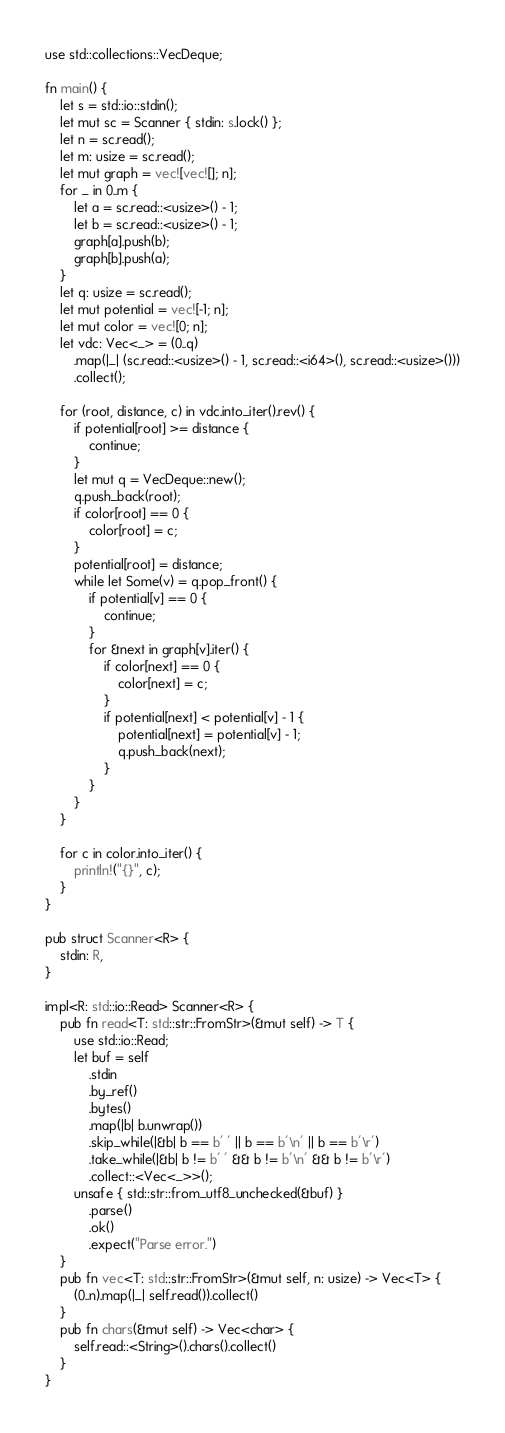<code> <loc_0><loc_0><loc_500><loc_500><_Rust_>use std::collections::VecDeque;

fn main() {
    let s = std::io::stdin();
    let mut sc = Scanner { stdin: s.lock() };
    let n = sc.read();
    let m: usize = sc.read();
    let mut graph = vec![vec![]; n];
    for _ in 0..m {
        let a = sc.read::<usize>() - 1;
        let b = sc.read::<usize>() - 1;
        graph[a].push(b);
        graph[b].push(a);
    }
    let q: usize = sc.read();
    let mut potential = vec![-1; n];
    let mut color = vec![0; n];
    let vdc: Vec<_> = (0..q)
        .map(|_| (sc.read::<usize>() - 1, sc.read::<i64>(), sc.read::<usize>()))
        .collect();

    for (root, distance, c) in vdc.into_iter().rev() {
        if potential[root] >= distance {
            continue;
        }
        let mut q = VecDeque::new();
        q.push_back(root);
        if color[root] == 0 {
            color[root] = c;
        }
        potential[root] = distance;
        while let Some(v) = q.pop_front() {
            if potential[v] == 0 {
                continue;
            }
            for &next in graph[v].iter() {
                if color[next] == 0 {
                    color[next] = c;
                }
                if potential[next] < potential[v] - 1 {
                    potential[next] = potential[v] - 1;
                    q.push_back(next);
                }
            }
        }
    }

    for c in color.into_iter() {
        println!("{}", c);
    }
}

pub struct Scanner<R> {
    stdin: R,
}

impl<R: std::io::Read> Scanner<R> {
    pub fn read<T: std::str::FromStr>(&mut self) -> T {
        use std::io::Read;
        let buf = self
            .stdin
            .by_ref()
            .bytes()
            .map(|b| b.unwrap())
            .skip_while(|&b| b == b' ' || b == b'\n' || b == b'\r')
            .take_while(|&b| b != b' ' && b != b'\n' && b != b'\r')
            .collect::<Vec<_>>();
        unsafe { std::str::from_utf8_unchecked(&buf) }
            .parse()
            .ok()
            .expect("Parse error.")
    }
    pub fn vec<T: std::str::FromStr>(&mut self, n: usize) -> Vec<T> {
        (0..n).map(|_| self.read()).collect()
    }
    pub fn chars(&mut self) -> Vec<char> {
        self.read::<String>().chars().collect()
    }
}
</code> 